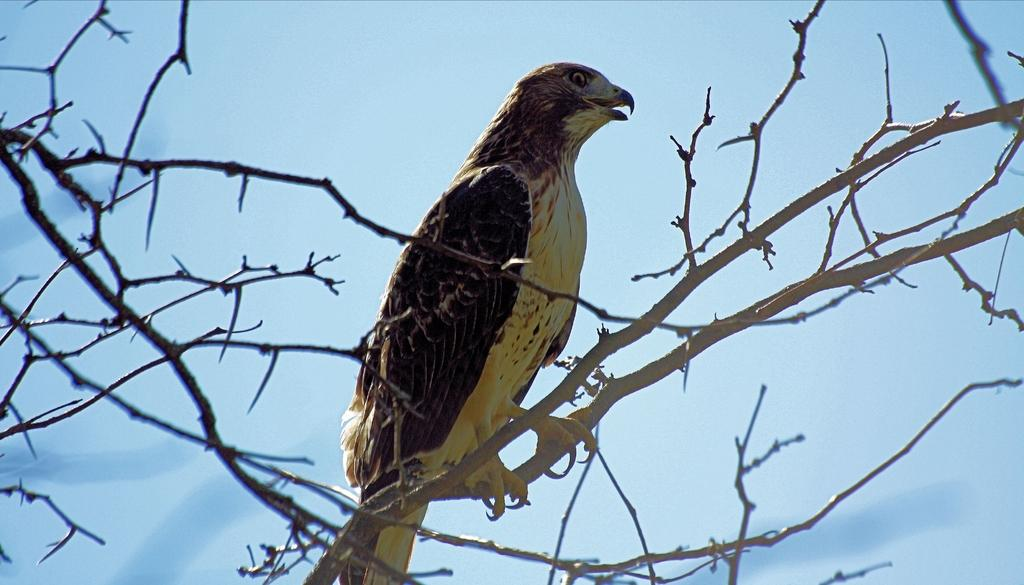What animal can be seen in the image? There is an eagle in the image. Where is the eagle located? The eagle is standing on a tree. What is the condition of the tree? The tree has no leaves. What can be seen in the background of the image? There is a sky visible in the background of the image. What type of pets are visible in the image? There are no pets visible in the image; it features an eagle standing on a tree with no leaves. 